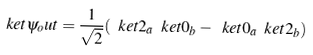<formula> <loc_0><loc_0><loc_500><loc_500>\ k e t { \psi _ { o } u t } = \frac { 1 } { \sqrt { 2 } } ( \ k e t { 2 } _ { a } \ k e t { 0 } _ { b } - \ k e t { 0 } _ { a } \ k e t { 2 } _ { b } )</formula> 